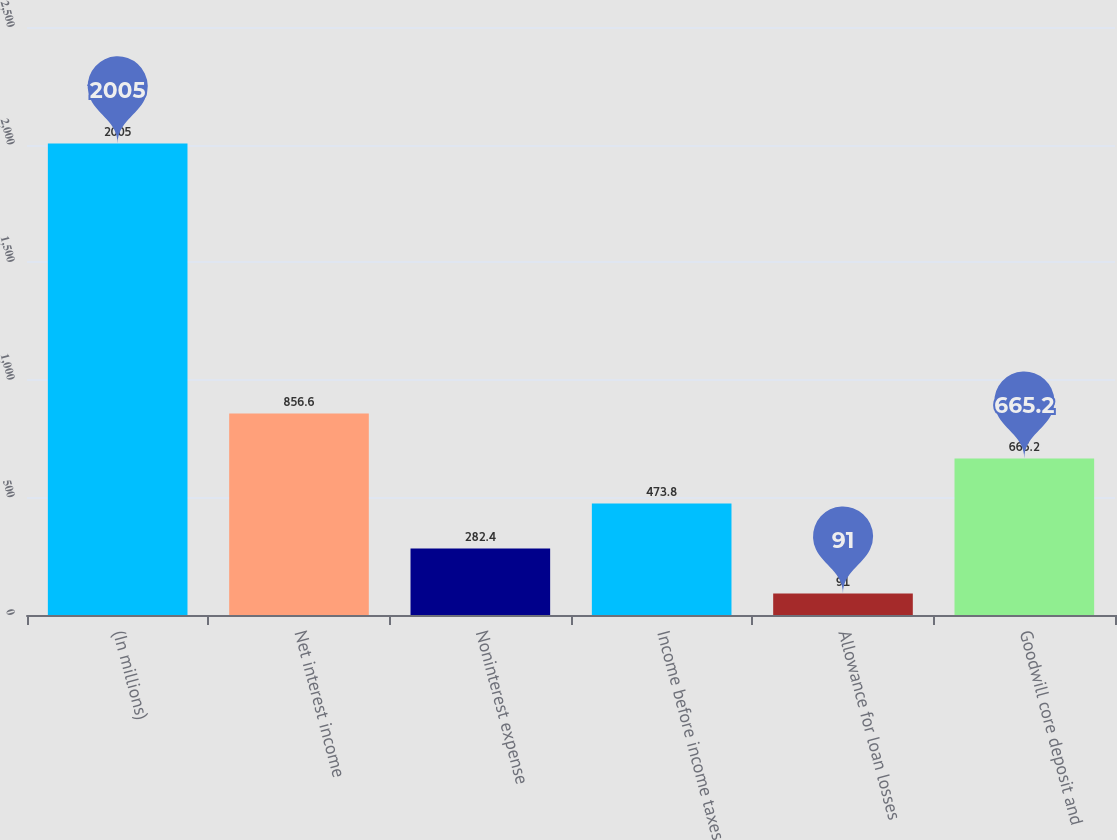Convert chart. <chart><loc_0><loc_0><loc_500><loc_500><bar_chart><fcel>(In millions)<fcel>Net interest income<fcel>Noninterest expense<fcel>Income before income taxes<fcel>Allowance for loan losses<fcel>Goodwill core deposit and<nl><fcel>2005<fcel>856.6<fcel>282.4<fcel>473.8<fcel>91<fcel>665.2<nl></chart> 